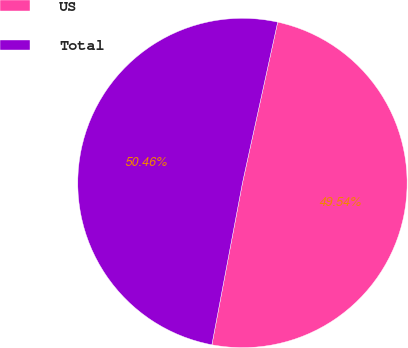Convert chart. <chart><loc_0><loc_0><loc_500><loc_500><pie_chart><fcel>US<fcel>Total<nl><fcel>49.54%<fcel>50.46%<nl></chart> 